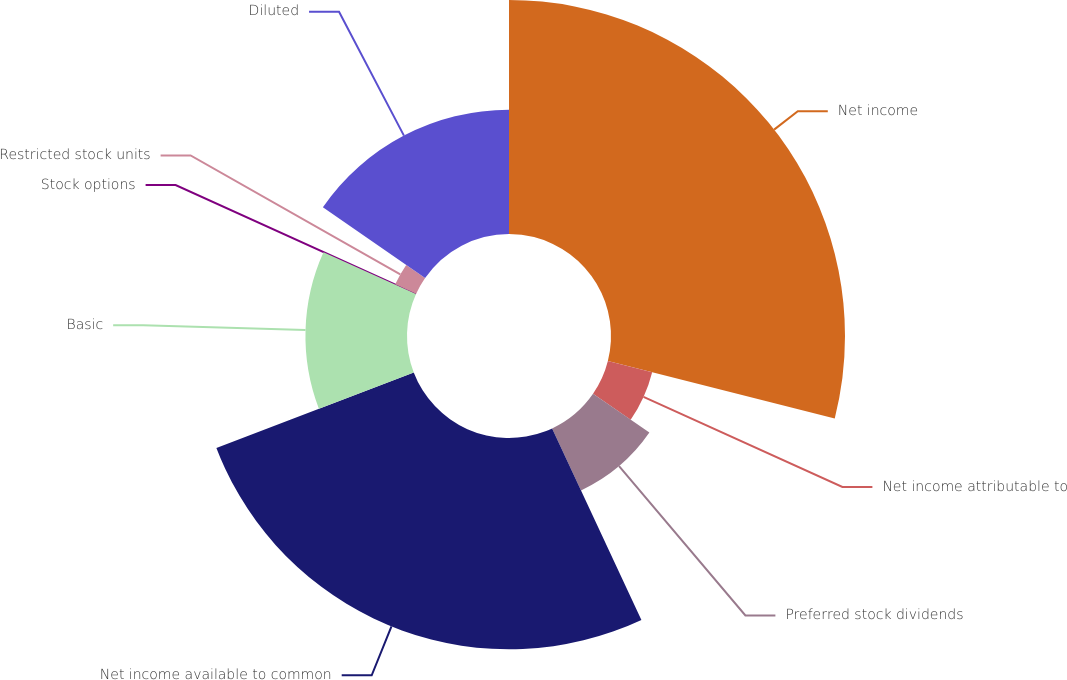Convert chart to OTSL. <chart><loc_0><loc_0><loc_500><loc_500><pie_chart><fcel>Net income<fcel>Net income attributable to<fcel>Preferred stock dividends<fcel>Net income available to common<fcel>Basic<fcel>Stock options<fcel>Restricted stock units<fcel>Diluted<nl><fcel>28.94%<fcel>5.65%<fcel>8.46%<fcel>26.13%<fcel>12.56%<fcel>0.04%<fcel>2.84%<fcel>15.37%<nl></chart> 